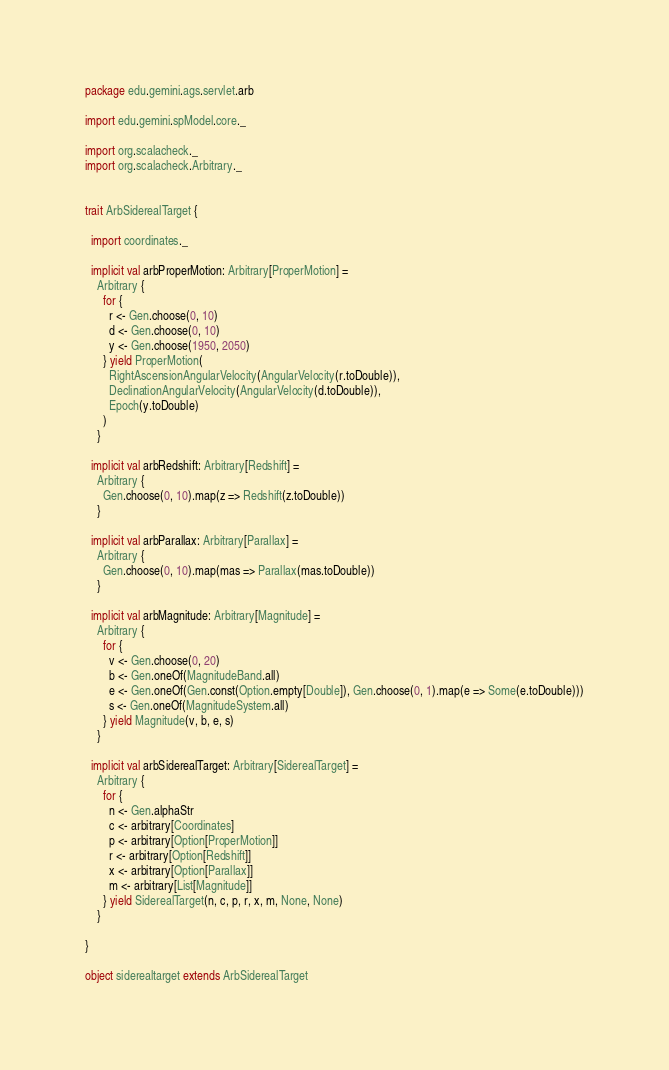<code> <loc_0><loc_0><loc_500><loc_500><_Scala_>package edu.gemini.ags.servlet.arb

import edu.gemini.spModel.core._

import org.scalacheck._
import org.scalacheck.Arbitrary._


trait ArbSiderealTarget {

  import coordinates._

  implicit val arbProperMotion: Arbitrary[ProperMotion] =
    Arbitrary {
      for {
        r <- Gen.choose(0, 10)
        d <- Gen.choose(0, 10)
        y <- Gen.choose(1950, 2050)
      } yield ProperMotion(
        RightAscensionAngularVelocity(AngularVelocity(r.toDouble)),
        DeclinationAngularVelocity(AngularVelocity(d.toDouble)),
        Epoch(y.toDouble)
      )
    }

  implicit val arbRedshift: Arbitrary[Redshift] =
    Arbitrary {
      Gen.choose(0, 10).map(z => Redshift(z.toDouble))
    }

  implicit val arbParallax: Arbitrary[Parallax] =
    Arbitrary {
      Gen.choose(0, 10).map(mas => Parallax(mas.toDouble))
    }

  implicit val arbMagnitude: Arbitrary[Magnitude] =
    Arbitrary {
      for {
        v <- Gen.choose(0, 20)
        b <- Gen.oneOf(MagnitudeBand.all)
        e <- Gen.oneOf(Gen.const(Option.empty[Double]), Gen.choose(0, 1).map(e => Some(e.toDouble)))
        s <- Gen.oneOf(MagnitudeSystem.all)
      } yield Magnitude(v, b, e, s)
    }

  implicit val arbSiderealTarget: Arbitrary[SiderealTarget] =
    Arbitrary {
      for {
        n <- Gen.alphaStr
        c <- arbitrary[Coordinates]
        p <- arbitrary[Option[ProperMotion]]
        r <- arbitrary[Option[Redshift]]
        x <- arbitrary[Option[Parallax]]
        m <- arbitrary[List[Magnitude]]
      } yield SiderealTarget(n, c, p, r, x, m, None, None)
    }

}

object siderealtarget extends ArbSiderealTarget
</code> 